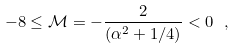Convert formula to latex. <formula><loc_0><loc_0><loc_500><loc_500>- 8 \leq { \mathcal { M } } = - \frac { 2 } { ( \alpha ^ { 2 } + 1 / 4 ) } < 0 \ ,</formula> 